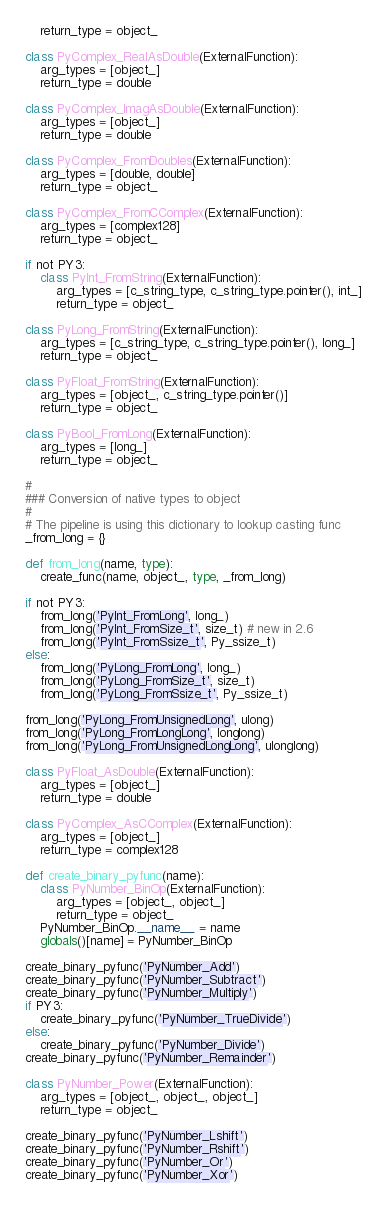Convert code to text. <code><loc_0><loc_0><loc_500><loc_500><_Python_>    return_type = object_

class PyComplex_RealAsDouble(ExternalFunction):
    arg_types = [object_]
    return_type = double

class PyComplex_ImagAsDouble(ExternalFunction):
    arg_types = [object_]
    return_type = double

class PyComplex_FromDoubles(ExternalFunction):
    arg_types = [double, double]
    return_type = object_

class PyComplex_FromCComplex(ExternalFunction):
    arg_types = [complex128]
    return_type = object_

if not PY3:
    class PyInt_FromString(ExternalFunction):
        arg_types = [c_string_type, c_string_type.pointer(), int_]
        return_type = object_

class PyLong_FromString(ExternalFunction):
    arg_types = [c_string_type, c_string_type.pointer(), long_]
    return_type = object_

class PyFloat_FromString(ExternalFunction):
    arg_types = [object_, c_string_type.pointer()]
    return_type = object_

class PyBool_FromLong(ExternalFunction):
    arg_types = [long_]
    return_type = object_

#
### Conversion of native types to object
#
# The pipeline is using this dictionary to lookup casting func
_from_long = {}

def from_long(name, type):
    create_func(name, object_, type, _from_long)

if not PY3:
    from_long('PyInt_FromLong', long_)
    from_long('PyInt_FromSize_t', size_t) # new in 2.6
    from_long('PyInt_FromSsize_t', Py_ssize_t)
else:
    from_long('PyLong_FromLong', long_)
    from_long('PyLong_FromSize_t', size_t)
    from_long('PyLong_FromSsize_t', Py_ssize_t)

from_long('PyLong_FromUnsignedLong', ulong)
from_long('PyLong_FromLongLong', longlong)
from_long('PyLong_FromUnsignedLongLong', ulonglong)

class PyFloat_AsDouble(ExternalFunction):
    arg_types = [object_]
    return_type = double

class PyComplex_AsCComplex(ExternalFunction):
    arg_types = [object_]
    return_type = complex128

def create_binary_pyfunc(name):
    class PyNumber_BinOp(ExternalFunction):
        arg_types = [object_, object_]
        return_type = object_
    PyNumber_BinOp.__name__ = name
    globals()[name] = PyNumber_BinOp

create_binary_pyfunc('PyNumber_Add')
create_binary_pyfunc('PyNumber_Subtract')
create_binary_pyfunc('PyNumber_Multiply')
if PY3:
    create_binary_pyfunc('PyNumber_TrueDivide')
else:
    create_binary_pyfunc('PyNumber_Divide')
create_binary_pyfunc('PyNumber_Remainder')

class PyNumber_Power(ExternalFunction):
    arg_types = [object_, object_, object_]
    return_type = object_

create_binary_pyfunc('PyNumber_Lshift')
create_binary_pyfunc('PyNumber_Rshift')
create_binary_pyfunc('PyNumber_Or')
create_binary_pyfunc('PyNumber_Xor')</code> 